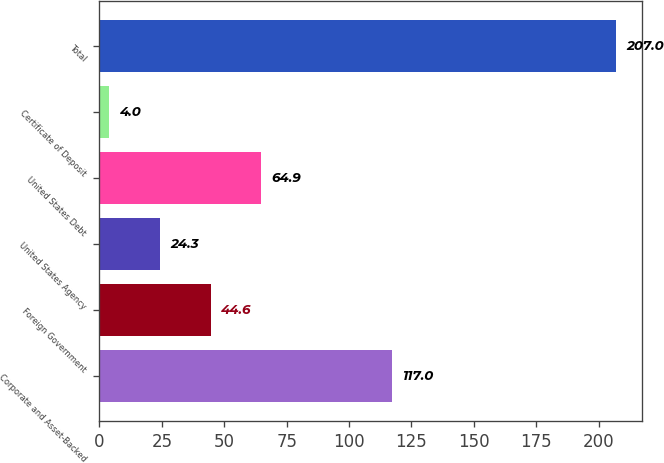Convert chart. <chart><loc_0><loc_0><loc_500><loc_500><bar_chart><fcel>Corporate and Asset-Backed<fcel>Foreign Government<fcel>United States Agency<fcel>United States Debt<fcel>Certificate of Deposit<fcel>Total<nl><fcel>117<fcel>44.6<fcel>24.3<fcel>64.9<fcel>4<fcel>207<nl></chart> 